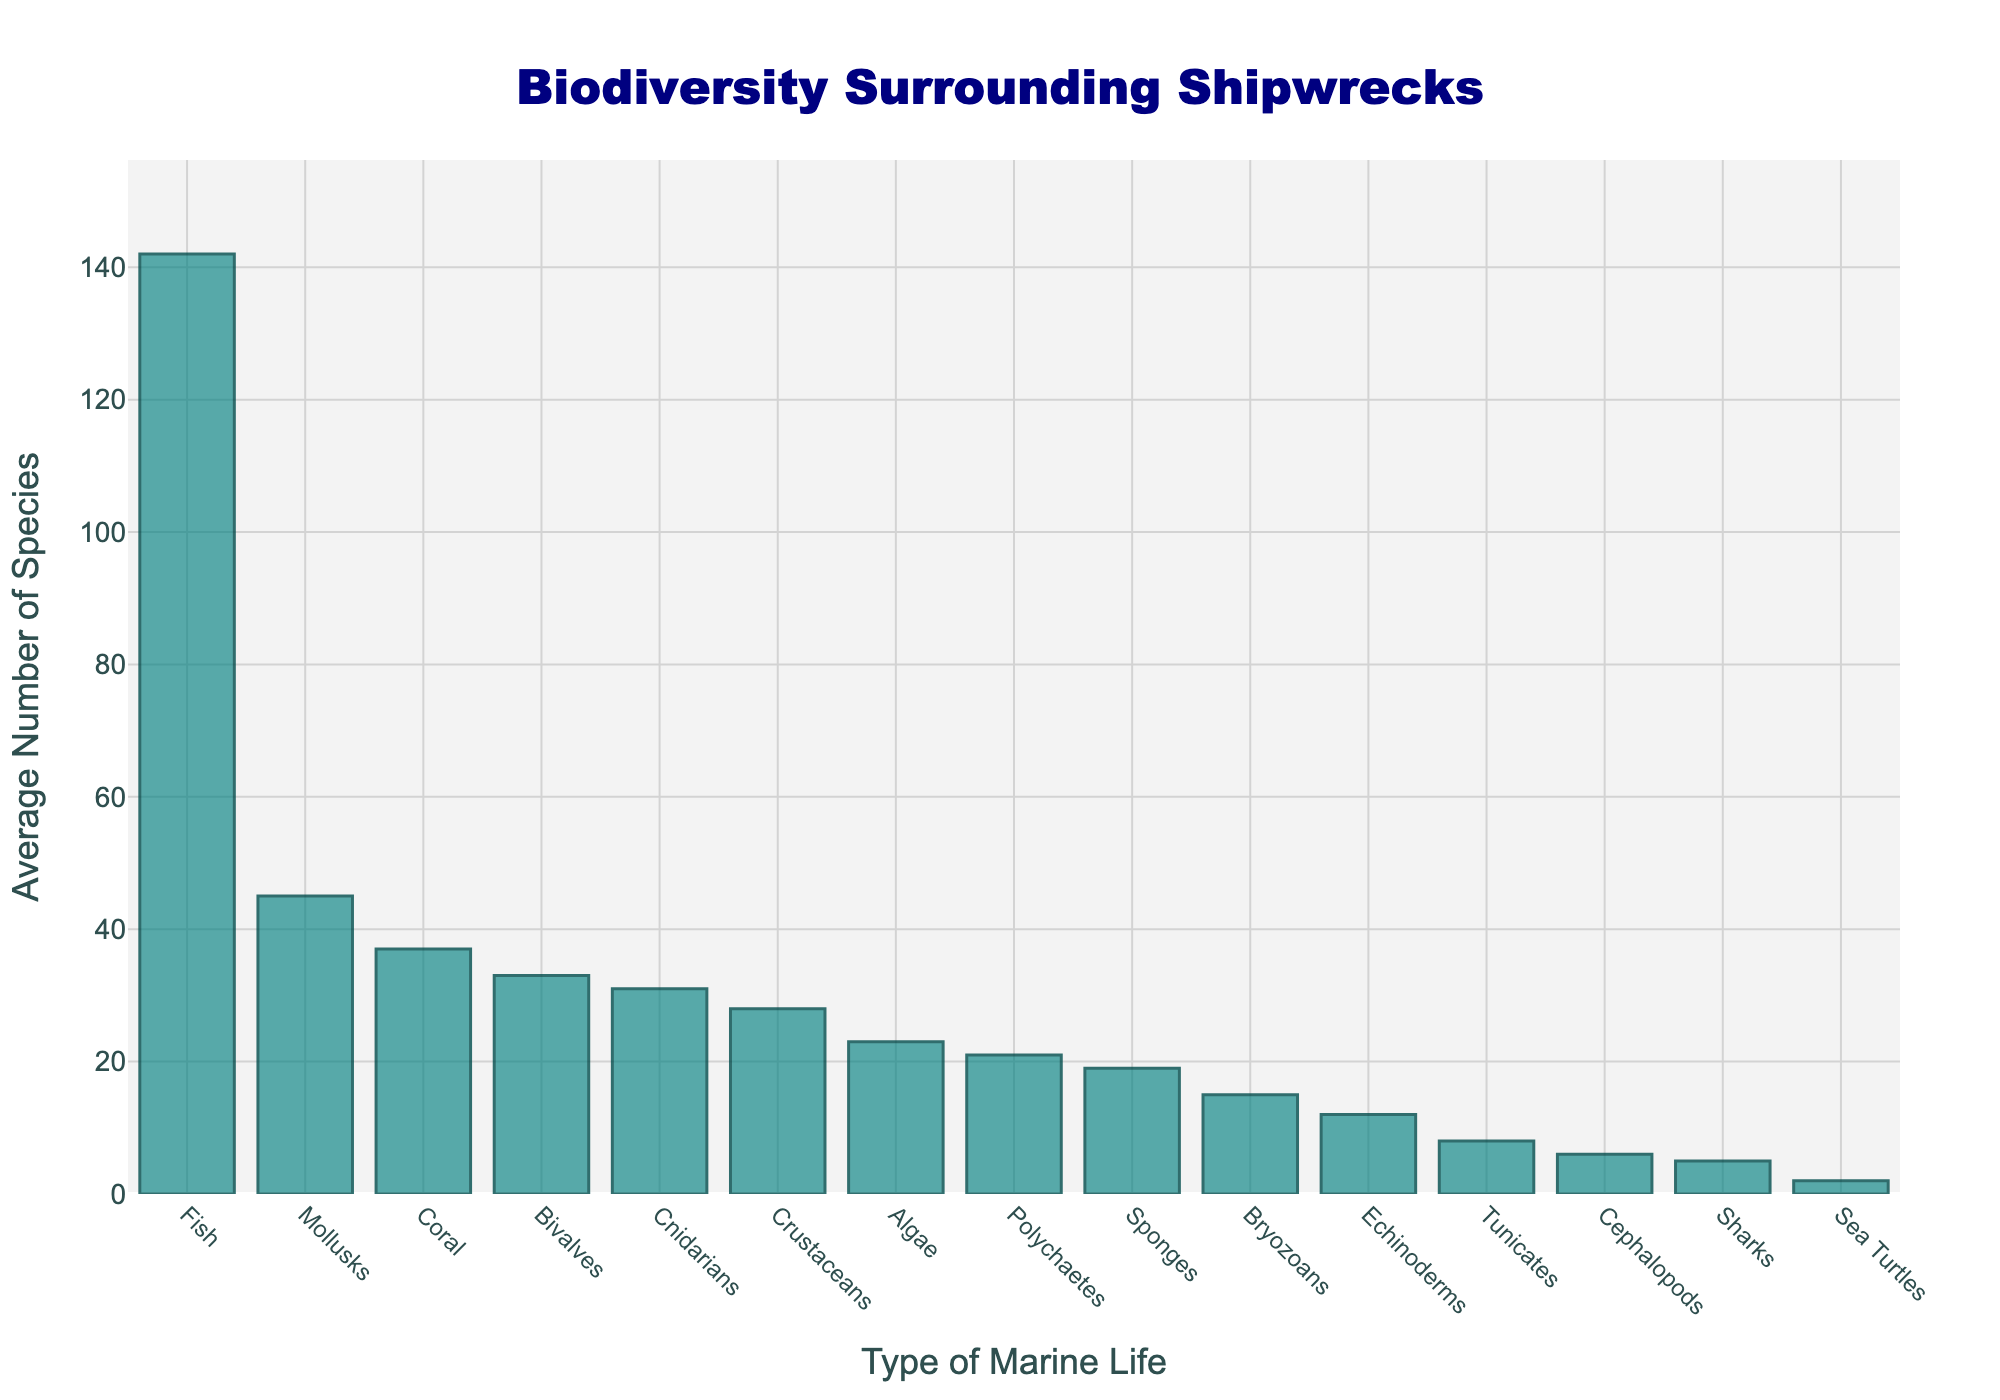What type of marine life has the highest average number of species? The bar representing "Fish" is the tallest in the chart, indicating the highest average number of species. Comparing all bars visually, "Fish" is the highest.
Answer: Fish How many more species on average are Fish compared to Coral? Find the height of the bars for both "Fish" and "Coral", and subtract the average value of Coral from the average value of Fish (142 - 37 = 105).
Answer: 105 Which types of marine life have fewer than 10 species on average? Visually inspect the heights of the bars to see which ones are lower than the 10-species mark on the y-axis. "Sea Turtles", "Cephalopods", and "Sharks" all fall below this threshold.
Answer: Sea Turtles, Cephalopods, Sharks What's the total average number of species for Mollusks, Sponges, and Bryozoans combined? Sum the average numbers for Mollusks, Sponges, and Bryozoans: 45 + 19 + 15 = 79.
Answer: 79 Are there more average species of Cnidarians or Bryozoans? Compare the height of the bars for "Cnidarians" and "Bryozoans". The bar for Cnidarians is taller (31) than the bar for Bryozoans (15).
Answer: Cnidarians Which type of marine life has the fewest average number of species? Identify the shortest bar in the chart, which is for "Sea Turtles" with an average of 2 species.
Answer: Sea Turtles Is the average number of Coral species greater than the average number of Crustacean species? Compare the height of the "Coral" and "Crustaceans" bars. Coral has 37 species, and Crustaceans have 28, so Coral is greater.
Answer: Yes What is the range of average species numbers for all types of marine life depicted in the chart? Subtract the smallest average number (Sea Turtles, 2) from the largest average number (Fish, 142): 142 - 2 = 140.
Answer: 140 What is the median value of the average number of species for the types of marine life listed? List the average numbers in ascending order: 2, 5, 6, 8, 12, 15, 19, 21, 23, 28, 31, 33, 37, 45, 142. The median value is the middle number of this ordered list, which is 23 (Algae).
Answer: 23 